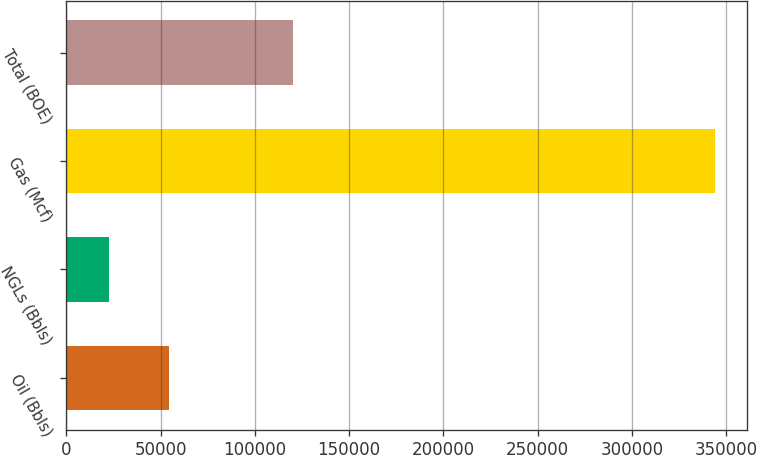<chart> <loc_0><loc_0><loc_500><loc_500><bar_chart><fcel>Oil (Bbls)<fcel>NGLs (Bbls)<fcel>Gas (Mcf)<fcel>Total (BOE)<nl><fcel>54626.2<fcel>22487<fcel>343879<fcel>120418<nl></chart> 